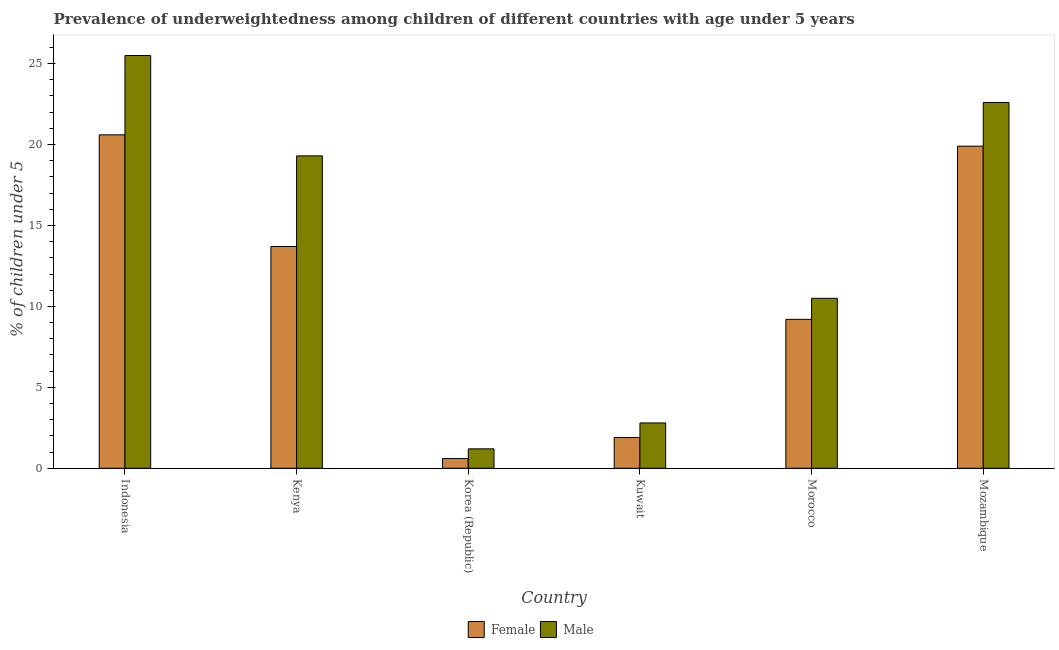How many groups of bars are there?
Your response must be concise. 6. Are the number of bars per tick equal to the number of legend labels?
Ensure brevity in your answer.  Yes. How many bars are there on the 3rd tick from the left?
Give a very brief answer. 2. What is the percentage of underweighted male children in Kenya?
Your response must be concise. 19.3. Across all countries, what is the maximum percentage of underweighted female children?
Provide a short and direct response. 20.6. Across all countries, what is the minimum percentage of underweighted male children?
Provide a short and direct response. 1.2. In which country was the percentage of underweighted female children maximum?
Make the answer very short. Indonesia. In which country was the percentage of underweighted female children minimum?
Provide a succinct answer. Korea (Republic). What is the total percentage of underweighted male children in the graph?
Your answer should be compact. 81.9. What is the difference between the percentage of underweighted male children in Kenya and that in Mozambique?
Your answer should be compact. -3.3. What is the difference between the percentage of underweighted male children in Morocco and the percentage of underweighted female children in Kuwait?
Offer a terse response. 8.6. What is the average percentage of underweighted female children per country?
Provide a succinct answer. 10.98. What is the difference between the percentage of underweighted female children and percentage of underweighted male children in Morocco?
Your answer should be very brief. -1.3. What is the ratio of the percentage of underweighted male children in Indonesia to that in Morocco?
Give a very brief answer. 2.43. Is the difference between the percentage of underweighted male children in Kuwait and Morocco greater than the difference between the percentage of underweighted female children in Kuwait and Morocco?
Ensure brevity in your answer.  No. What is the difference between the highest and the second highest percentage of underweighted male children?
Make the answer very short. 2.9. What is the difference between the highest and the lowest percentage of underweighted female children?
Make the answer very short. 20. In how many countries, is the percentage of underweighted male children greater than the average percentage of underweighted male children taken over all countries?
Provide a short and direct response. 3. What does the 2nd bar from the right in Morocco represents?
Provide a succinct answer. Female. How many bars are there?
Your answer should be very brief. 12. Are all the bars in the graph horizontal?
Keep it short and to the point. No. Are the values on the major ticks of Y-axis written in scientific E-notation?
Offer a very short reply. No. Does the graph contain grids?
Give a very brief answer. No. What is the title of the graph?
Provide a short and direct response. Prevalence of underweightedness among children of different countries with age under 5 years. What is the label or title of the Y-axis?
Offer a terse response.  % of children under 5. What is the  % of children under 5 of Female in Indonesia?
Give a very brief answer. 20.6. What is the  % of children under 5 of Male in Indonesia?
Your answer should be very brief. 25.5. What is the  % of children under 5 of Female in Kenya?
Make the answer very short. 13.7. What is the  % of children under 5 of Male in Kenya?
Ensure brevity in your answer.  19.3. What is the  % of children under 5 in Female in Korea (Republic)?
Ensure brevity in your answer.  0.6. What is the  % of children under 5 in Male in Korea (Republic)?
Offer a very short reply. 1.2. What is the  % of children under 5 of Female in Kuwait?
Keep it short and to the point. 1.9. What is the  % of children under 5 in Male in Kuwait?
Provide a succinct answer. 2.8. What is the  % of children under 5 of Female in Morocco?
Ensure brevity in your answer.  9.2. What is the  % of children under 5 of Female in Mozambique?
Offer a very short reply. 19.9. What is the  % of children under 5 in Male in Mozambique?
Make the answer very short. 22.6. Across all countries, what is the maximum  % of children under 5 in Female?
Keep it short and to the point. 20.6. Across all countries, what is the maximum  % of children under 5 in Male?
Keep it short and to the point. 25.5. Across all countries, what is the minimum  % of children under 5 of Female?
Provide a short and direct response. 0.6. Across all countries, what is the minimum  % of children under 5 of Male?
Your response must be concise. 1.2. What is the total  % of children under 5 in Female in the graph?
Make the answer very short. 65.9. What is the total  % of children under 5 in Male in the graph?
Provide a short and direct response. 81.9. What is the difference between the  % of children under 5 in Male in Indonesia and that in Kenya?
Make the answer very short. 6.2. What is the difference between the  % of children under 5 in Male in Indonesia and that in Korea (Republic)?
Offer a terse response. 24.3. What is the difference between the  % of children under 5 of Female in Indonesia and that in Kuwait?
Your answer should be very brief. 18.7. What is the difference between the  % of children under 5 in Male in Indonesia and that in Kuwait?
Provide a short and direct response. 22.7. What is the difference between the  % of children under 5 of Male in Indonesia and that in Morocco?
Offer a terse response. 15. What is the difference between the  % of children under 5 of Female in Indonesia and that in Mozambique?
Your answer should be compact. 0.7. What is the difference between the  % of children under 5 in Male in Indonesia and that in Mozambique?
Your response must be concise. 2.9. What is the difference between the  % of children under 5 of Female in Kenya and that in Korea (Republic)?
Offer a very short reply. 13.1. What is the difference between the  % of children under 5 of Male in Kenya and that in Kuwait?
Keep it short and to the point. 16.5. What is the difference between the  % of children under 5 in Female in Kenya and that in Morocco?
Your answer should be compact. 4.5. What is the difference between the  % of children under 5 in Female in Kenya and that in Mozambique?
Give a very brief answer. -6.2. What is the difference between the  % of children under 5 of Male in Kenya and that in Mozambique?
Keep it short and to the point. -3.3. What is the difference between the  % of children under 5 in Male in Korea (Republic) and that in Morocco?
Make the answer very short. -9.3. What is the difference between the  % of children under 5 in Female in Korea (Republic) and that in Mozambique?
Ensure brevity in your answer.  -19.3. What is the difference between the  % of children under 5 in Male in Korea (Republic) and that in Mozambique?
Make the answer very short. -21.4. What is the difference between the  % of children under 5 of Female in Kuwait and that in Morocco?
Provide a succinct answer. -7.3. What is the difference between the  % of children under 5 in Male in Kuwait and that in Mozambique?
Provide a short and direct response. -19.8. What is the difference between the  % of children under 5 of Female in Indonesia and the  % of children under 5 of Male in Korea (Republic)?
Your answer should be compact. 19.4. What is the difference between the  % of children under 5 in Female in Indonesia and the  % of children under 5 in Male in Kuwait?
Give a very brief answer. 17.8. What is the difference between the  % of children under 5 of Female in Indonesia and the  % of children under 5 of Male in Morocco?
Your response must be concise. 10.1. What is the difference between the  % of children under 5 in Female in Kenya and the  % of children under 5 in Male in Korea (Republic)?
Ensure brevity in your answer.  12.5. What is the difference between the  % of children under 5 in Female in Kenya and the  % of children under 5 in Male in Mozambique?
Keep it short and to the point. -8.9. What is the difference between the  % of children under 5 in Female in Korea (Republic) and the  % of children under 5 in Male in Morocco?
Offer a terse response. -9.9. What is the difference between the  % of children under 5 of Female in Kuwait and the  % of children under 5 of Male in Morocco?
Ensure brevity in your answer.  -8.6. What is the difference between the  % of children under 5 in Female in Kuwait and the  % of children under 5 in Male in Mozambique?
Offer a very short reply. -20.7. What is the difference between the  % of children under 5 in Female in Morocco and the  % of children under 5 in Male in Mozambique?
Offer a very short reply. -13.4. What is the average  % of children under 5 in Female per country?
Offer a very short reply. 10.98. What is the average  % of children under 5 of Male per country?
Your answer should be compact. 13.65. What is the difference between the  % of children under 5 of Female and  % of children under 5 of Male in Kenya?
Offer a very short reply. -5.6. What is the difference between the  % of children under 5 in Female and  % of children under 5 in Male in Korea (Republic)?
Your response must be concise. -0.6. What is the difference between the  % of children under 5 of Female and  % of children under 5 of Male in Kuwait?
Give a very brief answer. -0.9. What is the ratio of the  % of children under 5 in Female in Indonesia to that in Kenya?
Your response must be concise. 1.5. What is the ratio of the  % of children under 5 of Male in Indonesia to that in Kenya?
Provide a short and direct response. 1.32. What is the ratio of the  % of children under 5 of Female in Indonesia to that in Korea (Republic)?
Offer a very short reply. 34.33. What is the ratio of the  % of children under 5 of Male in Indonesia to that in Korea (Republic)?
Your answer should be compact. 21.25. What is the ratio of the  % of children under 5 of Female in Indonesia to that in Kuwait?
Your response must be concise. 10.84. What is the ratio of the  % of children under 5 of Male in Indonesia to that in Kuwait?
Your answer should be very brief. 9.11. What is the ratio of the  % of children under 5 in Female in Indonesia to that in Morocco?
Give a very brief answer. 2.24. What is the ratio of the  % of children under 5 of Male in Indonesia to that in Morocco?
Your answer should be compact. 2.43. What is the ratio of the  % of children under 5 of Female in Indonesia to that in Mozambique?
Your answer should be compact. 1.04. What is the ratio of the  % of children under 5 of Male in Indonesia to that in Mozambique?
Give a very brief answer. 1.13. What is the ratio of the  % of children under 5 of Female in Kenya to that in Korea (Republic)?
Your answer should be very brief. 22.83. What is the ratio of the  % of children under 5 in Male in Kenya to that in Korea (Republic)?
Your answer should be very brief. 16.08. What is the ratio of the  % of children under 5 of Female in Kenya to that in Kuwait?
Your answer should be compact. 7.21. What is the ratio of the  % of children under 5 of Male in Kenya to that in Kuwait?
Provide a succinct answer. 6.89. What is the ratio of the  % of children under 5 in Female in Kenya to that in Morocco?
Provide a short and direct response. 1.49. What is the ratio of the  % of children under 5 of Male in Kenya to that in Morocco?
Your answer should be compact. 1.84. What is the ratio of the  % of children under 5 in Female in Kenya to that in Mozambique?
Provide a short and direct response. 0.69. What is the ratio of the  % of children under 5 of Male in Kenya to that in Mozambique?
Your response must be concise. 0.85. What is the ratio of the  % of children under 5 of Female in Korea (Republic) to that in Kuwait?
Offer a very short reply. 0.32. What is the ratio of the  % of children under 5 in Male in Korea (Republic) to that in Kuwait?
Make the answer very short. 0.43. What is the ratio of the  % of children under 5 of Female in Korea (Republic) to that in Morocco?
Offer a terse response. 0.07. What is the ratio of the  % of children under 5 of Male in Korea (Republic) to that in Morocco?
Make the answer very short. 0.11. What is the ratio of the  % of children under 5 in Female in Korea (Republic) to that in Mozambique?
Your answer should be very brief. 0.03. What is the ratio of the  % of children under 5 in Male in Korea (Republic) to that in Mozambique?
Ensure brevity in your answer.  0.05. What is the ratio of the  % of children under 5 of Female in Kuwait to that in Morocco?
Offer a very short reply. 0.21. What is the ratio of the  % of children under 5 of Male in Kuwait to that in Morocco?
Your response must be concise. 0.27. What is the ratio of the  % of children under 5 in Female in Kuwait to that in Mozambique?
Offer a terse response. 0.1. What is the ratio of the  % of children under 5 of Male in Kuwait to that in Mozambique?
Your answer should be very brief. 0.12. What is the ratio of the  % of children under 5 in Female in Morocco to that in Mozambique?
Keep it short and to the point. 0.46. What is the ratio of the  % of children under 5 in Male in Morocco to that in Mozambique?
Your answer should be very brief. 0.46. What is the difference between the highest and the second highest  % of children under 5 in Male?
Keep it short and to the point. 2.9. What is the difference between the highest and the lowest  % of children under 5 of Female?
Give a very brief answer. 20. What is the difference between the highest and the lowest  % of children under 5 in Male?
Give a very brief answer. 24.3. 